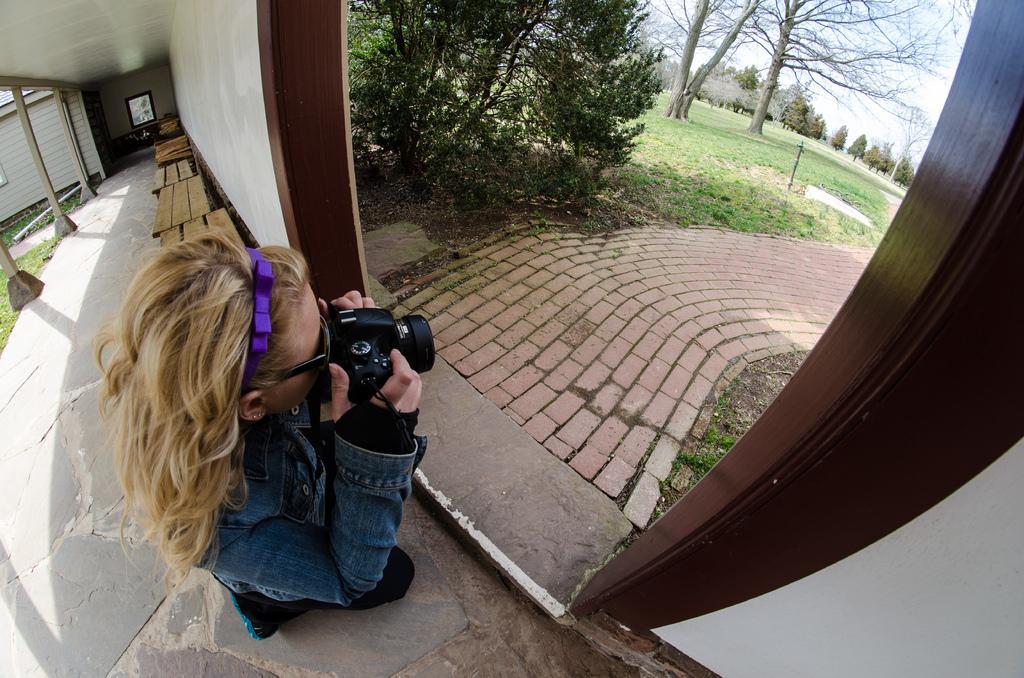Please provide a concise description of this image. Girl holding camera taking picture of trees and here there are benches. 